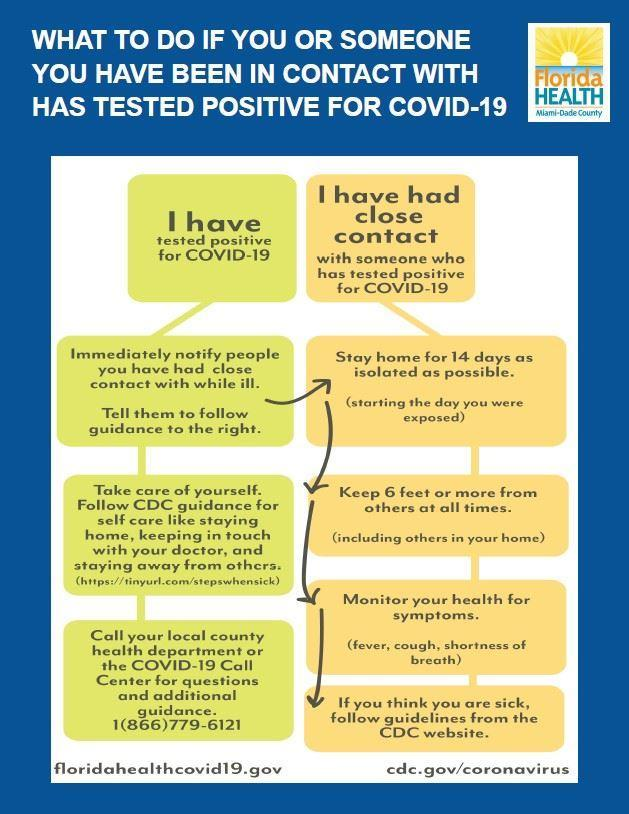What are the common indications one could get if he/she is Covid positive?
Answer the question with a short phrase. fever, cough, shortness of breath What is the color code given to the person who becomes Covid positive- red, green, blue, black? green What should be the next step after informing others when you are Covid positive? stay home for 14 days as isolated as possible From which day one should enter quarantine period? starting the day you were exposed What should be the distance to be maintained from others while in quarantine? 6 feet or more What is the color code given to the person who comes in primary contact of a Covid positive patient- red, yellow, blue, black? yellow What should be the immediate step when someone comes in direct contact list of a Covid positive patient? stay home for 14 days as isolated as possible What should be the immediate step when someone beliefs he/she is not well due to corona? follow guidelines from the CDC website 